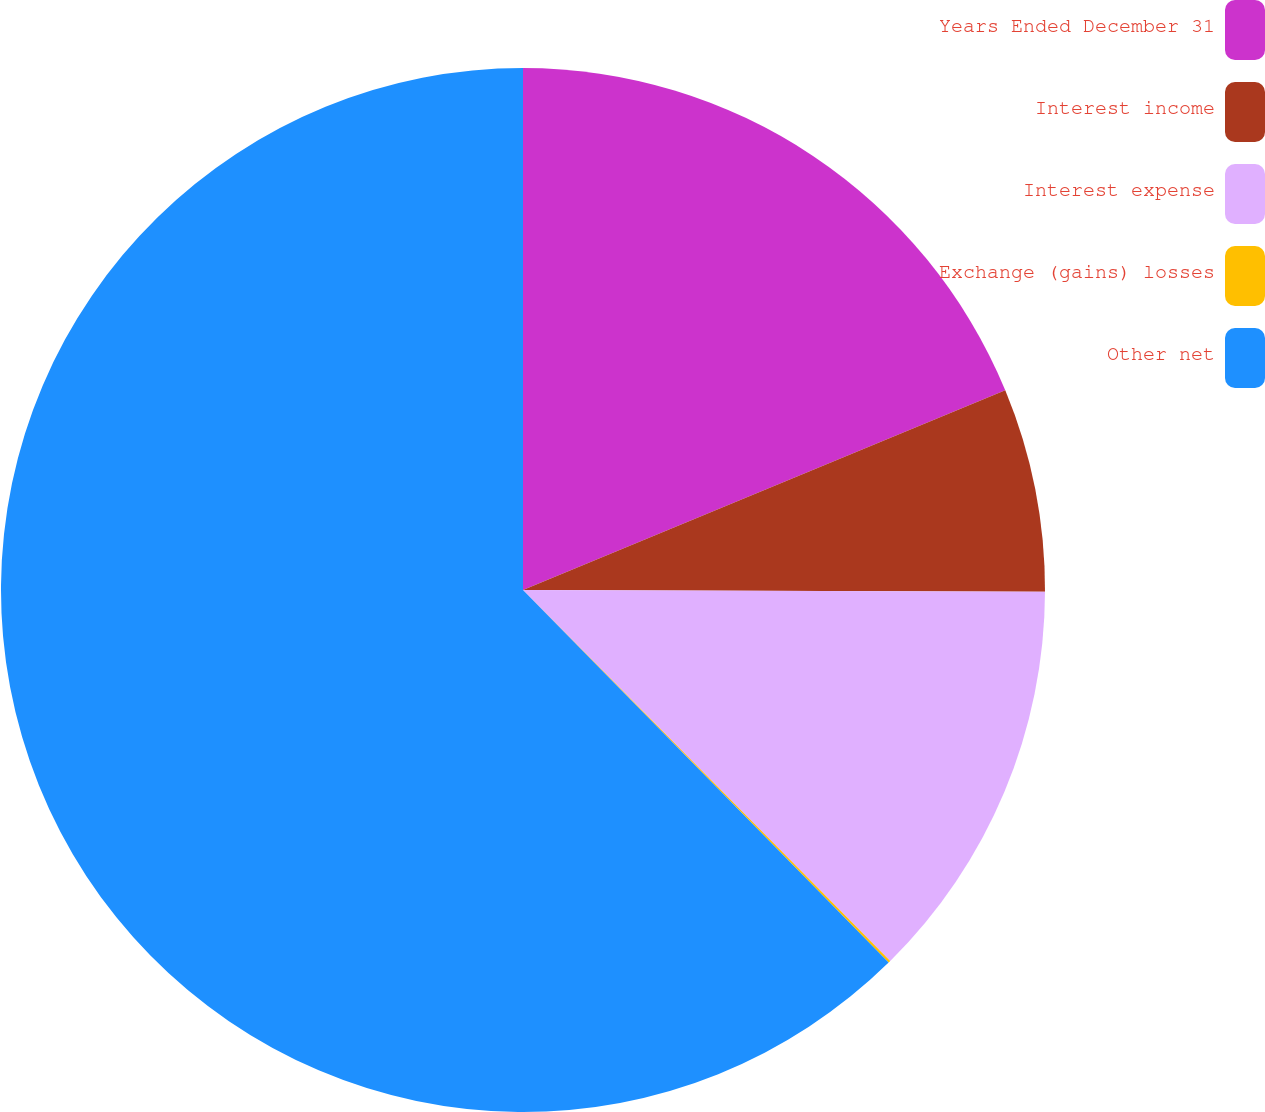Convert chart. <chart><loc_0><loc_0><loc_500><loc_500><pie_chart><fcel>Years Ended December 31<fcel>Interest income<fcel>Interest expense<fcel>Exchange (gains) losses<fcel>Other net<nl><fcel>18.75%<fcel>6.3%<fcel>12.53%<fcel>0.07%<fcel>62.35%<nl></chart> 